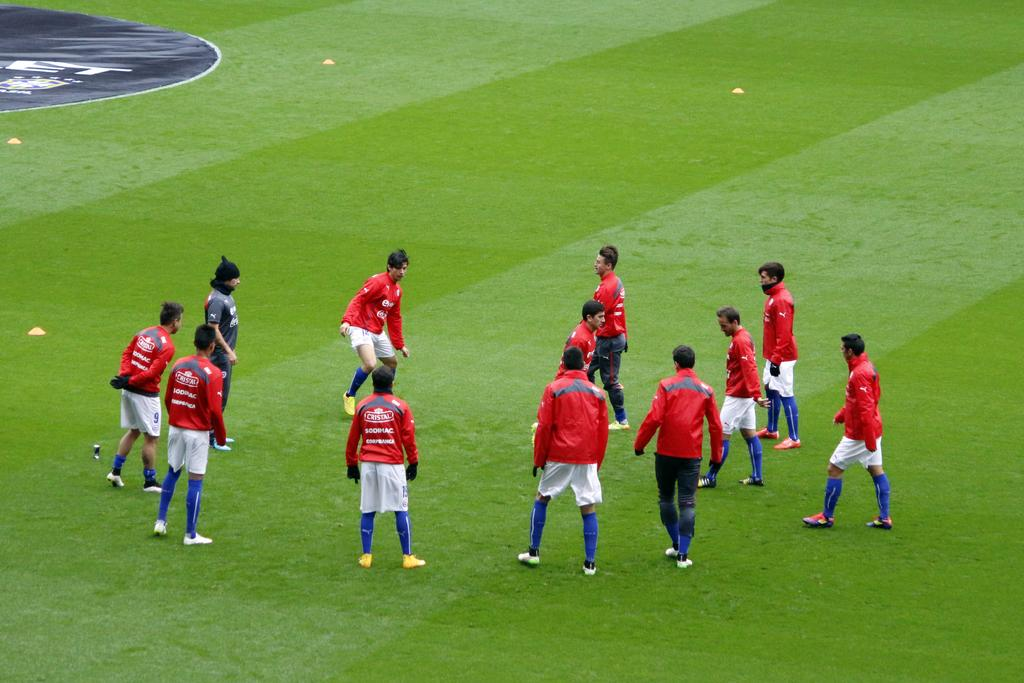What type of location is shown in the image? The image depicts a playground. Can you describe the people in the image? There is a group of people wearing red t-shirts and one person wearing a black t-shirt in the image. What is the ground made of in the image? Grass is present at the bottom of the image. What type of books can be seen in the library in the image? There is no library present in the image; it depicts a playground. What shape is the circle in the image? There is no circle present in the image. 